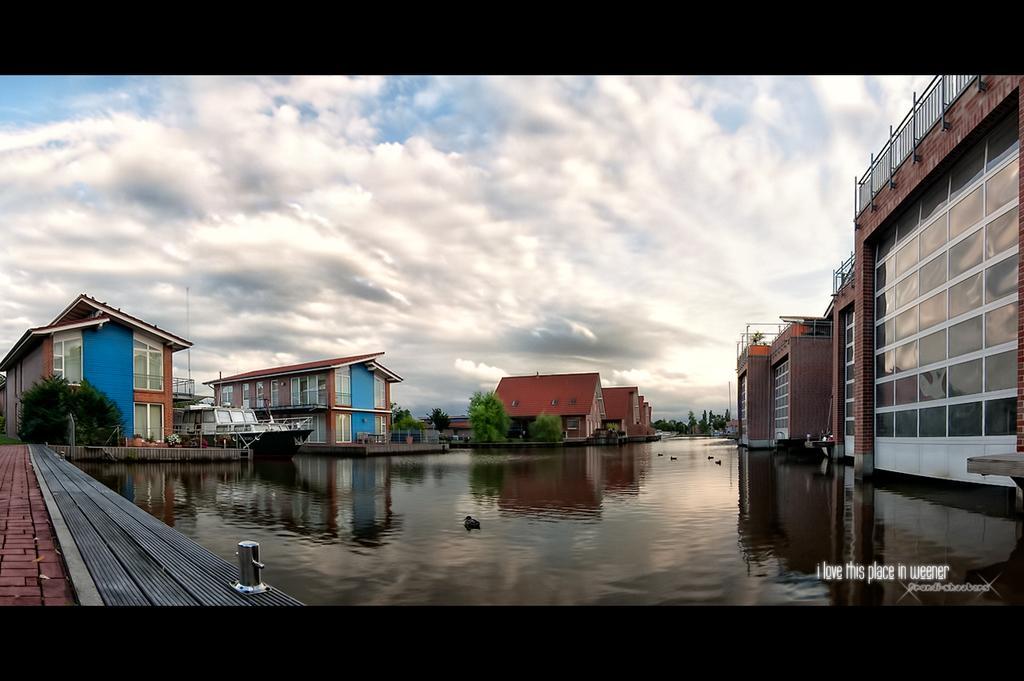Can you describe this image briefly? As we can see in the image there are buildings, windows, trees and water. At the top there is sky and clouds. 